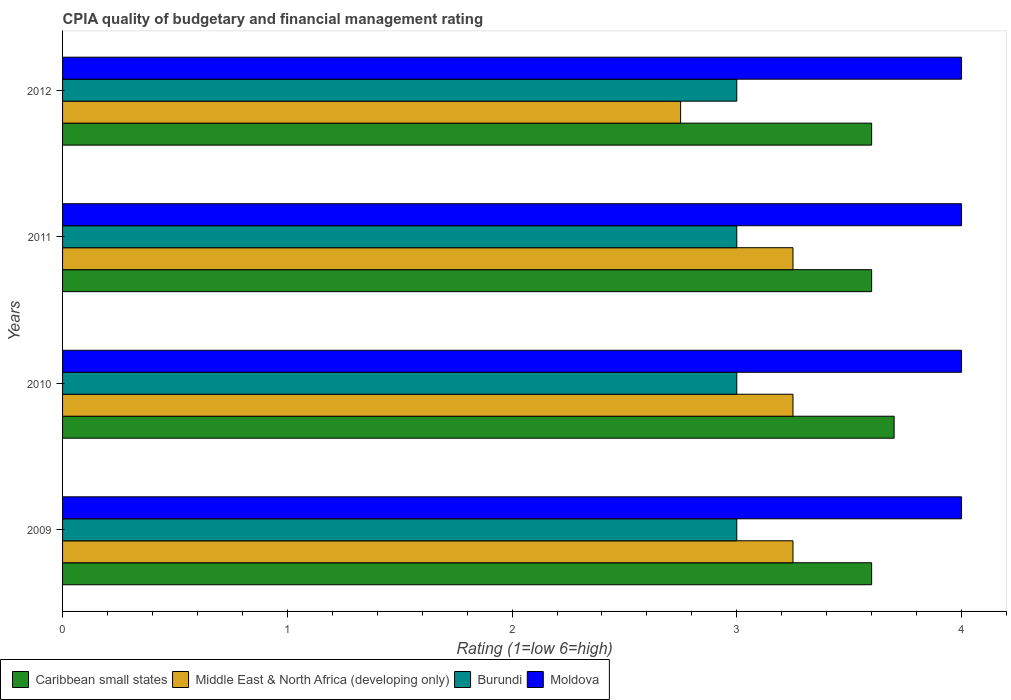How many different coloured bars are there?
Provide a short and direct response. 4. Are the number of bars on each tick of the Y-axis equal?
Your answer should be compact. Yes. In how many cases, is the number of bars for a given year not equal to the number of legend labels?
Make the answer very short. 0. What is the CPIA rating in Burundi in 2009?
Make the answer very short. 3. What is the difference between the CPIA rating in Moldova in 2009 and the CPIA rating in Caribbean small states in 2011?
Ensure brevity in your answer.  0.4. What is the ratio of the CPIA rating in Caribbean small states in 2010 to that in 2011?
Provide a succinct answer. 1.03. What is the difference between the highest and the lowest CPIA rating in Caribbean small states?
Offer a terse response. 0.1. In how many years, is the CPIA rating in Caribbean small states greater than the average CPIA rating in Caribbean small states taken over all years?
Offer a terse response. 1. Is it the case that in every year, the sum of the CPIA rating in Caribbean small states and CPIA rating in Burundi is greater than the sum of CPIA rating in Middle East & North Africa (developing only) and CPIA rating in Moldova?
Give a very brief answer. Yes. What does the 2nd bar from the top in 2011 represents?
Your answer should be compact. Burundi. What does the 4th bar from the bottom in 2011 represents?
Your answer should be compact. Moldova. How many bars are there?
Offer a terse response. 16. How many years are there in the graph?
Provide a short and direct response. 4. Does the graph contain grids?
Provide a short and direct response. No. How many legend labels are there?
Ensure brevity in your answer.  4. How are the legend labels stacked?
Make the answer very short. Horizontal. What is the title of the graph?
Keep it short and to the point. CPIA quality of budgetary and financial management rating. What is the label or title of the X-axis?
Ensure brevity in your answer.  Rating (1=low 6=high). What is the Rating (1=low 6=high) of Middle East & North Africa (developing only) in 2009?
Keep it short and to the point. 3.25. What is the Rating (1=low 6=high) in Caribbean small states in 2010?
Ensure brevity in your answer.  3.7. What is the Rating (1=low 6=high) of Moldova in 2010?
Ensure brevity in your answer.  4. What is the Rating (1=low 6=high) of Burundi in 2011?
Provide a succinct answer. 3. What is the Rating (1=low 6=high) in Middle East & North Africa (developing only) in 2012?
Provide a succinct answer. 2.75. What is the Rating (1=low 6=high) of Moldova in 2012?
Ensure brevity in your answer.  4. Across all years, what is the maximum Rating (1=low 6=high) of Caribbean small states?
Your answer should be very brief. 3.7. Across all years, what is the maximum Rating (1=low 6=high) in Moldova?
Your response must be concise. 4. Across all years, what is the minimum Rating (1=low 6=high) of Caribbean small states?
Ensure brevity in your answer.  3.6. Across all years, what is the minimum Rating (1=low 6=high) in Middle East & North Africa (developing only)?
Give a very brief answer. 2.75. Across all years, what is the minimum Rating (1=low 6=high) in Moldova?
Provide a short and direct response. 4. What is the total Rating (1=low 6=high) in Caribbean small states in the graph?
Provide a succinct answer. 14.5. What is the difference between the Rating (1=low 6=high) in Caribbean small states in 2009 and that in 2010?
Provide a short and direct response. -0.1. What is the difference between the Rating (1=low 6=high) of Middle East & North Africa (developing only) in 2009 and that in 2010?
Offer a very short reply. 0. What is the difference between the Rating (1=low 6=high) in Burundi in 2009 and that in 2010?
Your response must be concise. 0. What is the difference between the Rating (1=low 6=high) of Caribbean small states in 2009 and that in 2011?
Provide a succinct answer. 0. What is the difference between the Rating (1=low 6=high) in Caribbean small states in 2009 and that in 2012?
Offer a terse response. 0. What is the difference between the Rating (1=low 6=high) of Moldova in 2009 and that in 2012?
Give a very brief answer. 0. What is the difference between the Rating (1=low 6=high) of Middle East & North Africa (developing only) in 2010 and that in 2011?
Make the answer very short. 0. What is the difference between the Rating (1=low 6=high) in Moldova in 2010 and that in 2011?
Keep it short and to the point. 0. What is the difference between the Rating (1=low 6=high) of Caribbean small states in 2011 and that in 2012?
Give a very brief answer. 0. What is the difference between the Rating (1=low 6=high) of Middle East & North Africa (developing only) in 2011 and that in 2012?
Your answer should be compact. 0.5. What is the difference between the Rating (1=low 6=high) in Burundi in 2011 and that in 2012?
Provide a short and direct response. 0. What is the difference between the Rating (1=low 6=high) in Caribbean small states in 2009 and the Rating (1=low 6=high) in Burundi in 2010?
Your response must be concise. 0.6. What is the difference between the Rating (1=low 6=high) of Caribbean small states in 2009 and the Rating (1=low 6=high) of Moldova in 2010?
Keep it short and to the point. -0.4. What is the difference between the Rating (1=low 6=high) in Middle East & North Africa (developing only) in 2009 and the Rating (1=low 6=high) in Moldova in 2010?
Your response must be concise. -0.75. What is the difference between the Rating (1=low 6=high) of Burundi in 2009 and the Rating (1=low 6=high) of Moldova in 2010?
Your answer should be very brief. -1. What is the difference between the Rating (1=low 6=high) of Caribbean small states in 2009 and the Rating (1=low 6=high) of Burundi in 2011?
Provide a short and direct response. 0.6. What is the difference between the Rating (1=low 6=high) in Caribbean small states in 2009 and the Rating (1=low 6=high) in Moldova in 2011?
Provide a short and direct response. -0.4. What is the difference between the Rating (1=low 6=high) in Middle East & North Africa (developing only) in 2009 and the Rating (1=low 6=high) in Burundi in 2011?
Keep it short and to the point. 0.25. What is the difference between the Rating (1=low 6=high) of Middle East & North Africa (developing only) in 2009 and the Rating (1=low 6=high) of Moldova in 2011?
Offer a very short reply. -0.75. What is the difference between the Rating (1=low 6=high) in Caribbean small states in 2009 and the Rating (1=low 6=high) in Burundi in 2012?
Your response must be concise. 0.6. What is the difference between the Rating (1=low 6=high) in Caribbean small states in 2009 and the Rating (1=low 6=high) in Moldova in 2012?
Give a very brief answer. -0.4. What is the difference between the Rating (1=low 6=high) in Middle East & North Africa (developing only) in 2009 and the Rating (1=low 6=high) in Burundi in 2012?
Make the answer very short. 0.25. What is the difference between the Rating (1=low 6=high) in Middle East & North Africa (developing only) in 2009 and the Rating (1=low 6=high) in Moldova in 2012?
Offer a very short reply. -0.75. What is the difference between the Rating (1=low 6=high) of Burundi in 2009 and the Rating (1=low 6=high) of Moldova in 2012?
Your response must be concise. -1. What is the difference between the Rating (1=low 6=high) of Caribbean small states in 2010 and the Rating (1=low 6=high) of Middle East & North Africa (developing only) in 2011?
Ensure brevity in your answer.  0.45. What is the difference between the Rating (1=low 6=high) of Caribbean small states in 2010 and the Rating (1=low 6=high) of Burundi in 2011?
Your answer should be very brief. 0.7. What is the difference between the Rating (1=low 6=high) in Middle East & North Africa (developing only) in 2010 and the Rating (1=low 6=high) in Moldova in 2011?
Offer a terse response. -0.75. What is the difference between the Rating (1=low 6=high) of Burundi in 2010 and the Rating (1=low 6=high) of Moldova in 2011?
Make the answer very short. -1. What is the difference between the Rating (1=low 6=high) in Caribbean small states in 2010 and the Rating (1=low 6=high) in Middle East & North Africa (developing only) in 2012?
Offer a very short reply. 0.95. What is the difference between the Rating (1=low 6=high) of Caribbean small states in 2010 and the Rating (1=low 6=high) of Burundi in 2012?
Your answer should be very brief. 0.7. What is the difference between the Rating (1=low 6=high) in Middle East & North Africa (developing only) in 2010 and the Rating (1=low 6=high) in Moldova in 2012?
Give a very brief answer. -0.75. What is the difference between the Rating (1=low 6=high) of Burundi in 2010 and the Rating (1=low 6=high) of Moldova in 2012?
Provide a succinct answer. -1. What is the difference between the Rating (1=low 6=high) in Caribbean small states in 2011 and the Rating (1=low 6=high) in Middle East & North Africa (developing only) in 2012?
Your response must be concise. 0.85. What is the difference between the Rating (1=low 6=high) in Caribbean small states in 2011 and the Rating (1=low 6=high) in Burundi in 2012?
Your answer should be compact. 0.6. What is the difference between the Rating (1=low 6=high) of Middle East & North Africa (developing only) in 2011 and the Rating (1=low 6=high) of Moldova in 2012?
Your response must be concise. -0.75. What is the difference between the Rating (1=low 6=high) of Burundi in 2011 and the Rating (1=low 6=high) of Moldova in 2012?
Your answer should be very brief. -1. What is the average Rating (1=low 6=high) of Caribbean small states per year?
Give a very brief answer. 3.62. What is the average Rating (1=low 6=high) of Middle East & North Africa (developing only) per year?
Provide a short and direct response. 3.12. What is the average Rating (1=low 6=high) of Moldova per year?
Your response must be concise. 4. In the year 2009, what is the difference between the Rating (1=low 6=high) of Caribbean small states and Rating (1=low 6=high) of Moldova?
Your answer should be compact. -0.4. In the year 2009, what is the difference between the Rating (1=low 6=high) in Middle East & North Africa (developing only) and Rating (1=low 6=high) in Burundi?
Provide a short and direct response. 0.25. In the year 2009, what is the difference between the Rating (1=low 6=high) of Middle East & North Africa (developing only) and Rating (1=low 6=high) of Moldova?
Keep it short and to the point. -0.75. In the year 2010, what is the difference between the Rating (1=low 6=high) of Caribbean small states and Rating (1=low 6=high) of Middle East & North Africa (developing only)?
Give a very brief answer. 0.45. In the year 2010, what is the difference between the Rating (1=low 6=high) of Caribbean small states and Rating (1=low 6=high) of Burundi?
Make the answer very short. 0.7. In the year 2010, what is the difference between the Rating (1=low 6=high) of Middle East & North Africa (developing only) and Rating (1=low 6=high) of Burundi?
Your answer should be compact. 0.25. In the year 2010, what is the difference between the Rating (1=low 6=high) in Middle East & North Africa (developing only) and Rating (1=low 6=high) in Moldova?
Offer a terse response. -0.75. In the year 2011, what is the difference between the Rating (1=low 6=high) of Caribbean small states and Rating (1=low 6=high) of Burundi?
Give a very brief answer. 0.6. In the year 2011, what is the difference between the Rating (1=low 6=high) in Middle East & North Africa (developing only) and Rating (1=low 6=high) in Moldova?
Offer a terse response. -0.75. In the year 2011, what is the difference between the Rating (1=low 6=high) of Burundi and Rating (1=low 6=high) of Moldova?
Provide a succinct answer. -1. In the year 2012, what is the difference between the Rating (1=low 6=high) in Middle East & North Africa (developing only) and Rating (1=low 6=high) in Burundi?
Your answer should be very brief. -0.25. In the year 2012, what is the difference between the Rating (1=low 6=high) in Middle East & North Africa (developing only) and Rating (1=low 6=high) in Moldova?
Your answer should be very brief. -1.25. What is the ratio of the Rating (1=low 6=high) in Caribbean small states in 2009 to that in 2010?
Offer a very short reply. 0.97. What is the ratio of the Rating (1=low 6=high) in Burundi in 2009 to that in 2010?
Ensure brevity in your answer.  1. What is the ratio of the Rating (1=low 6=high) of Middle East & North Africa (developing only) in 2009 to that in 2011?
Your answer should be very brief. 1. What is the ratio of the Rating (1=low 6=high) of Burundi in 2009 to that in 2011?
Your answer should be very brief. 1. What is the ratio of the Rating (1=low 6=high) in Moldova in 2009 to that in 2011?
Offer a terse response. 1. What is the ratio of the Rating (1=low 6=high) in Caribbean small states in 2009 to that in 2012?
Your response must be concise. 1. What is the ratio of the Rating (1=low 6=high) of Middle East & North Africa (developing only) in 2009 to that in 2012?
Give a very brief answer. 1.18. What is the ratio of the Rating (1=low 6=high) of Burundi in 2009 to that in 2012?
Give a very brief answer. 1. What is the ratio of the Rating (1=low 6=high) of Caribbean small states in 2010 to that in 2011?
Ensure brevity in your answer.  1.03. What is the ratio of the Rating (1=low 6=high) in Middle East & North Africa (developing only) in 2010 to that in 2011?
Provide a succinct answer. 1. What is the ratio of the Rating (1=low 6=high) in Burundi in 2010 to that in 2011?
Offer a very short reply. 1. What is the ratio of the Rating (1=low 6=high) of Moldova in 2010 to that in 2011?
Give a very brief answer. 1. What is the ratio of the Rating (1=low 6=high) in Caribbean small states in 2010 to that in 2012?
Ensure brevity in your answer.  1.03. What is the ratio of the Rating (1=low 6=high) of Middle East & North Africa (developing only) in 2010 to that in 2012?
Offer a terse response. 1.18. What is the ratio of the Rating (1=low 6=high) in Burundi in 2010 to that in 2012?
Provide a succinct answer. 1. What is the ratio of the Rating (1=low 6=high) of Moldova in 2010 to that in 2012?
Your answer should be very brief. 1. What is the ratio of the Rating (1=low 6=high) in Caribbean small states in 2011 to that in 2012?
Offer a terse response. 1. What is the ratio of the Rating (1=low 6=high) in Middle East & North Africa (developing only) in 2011 to that in 2012?
Provide a short and direct response. 1.18. What is the difference between the highest and the second highest Rating (1=low 6=high) of Middle East & North Africa (developing only)?
Provide a succinct answer. 0. What is the difference between the highest and the lowest Rating (1=low 6=high) in Caribbean small states?
Ensure brevity in your answer.  0.1. What is the difference between the highest and the lowest Rating (1=low 6=high) of Middle East & North Africa (developing only)?
Provide a short and direct response. 0.5. What is the difference between the highest and the lowest Rating (1=low 6=high) of Burundi?
Provide a short and direct response. 0. What is the difference between the highest and the lowest Rating (1=low 6=high) in Moldova?
Offer a terse response. 0. 